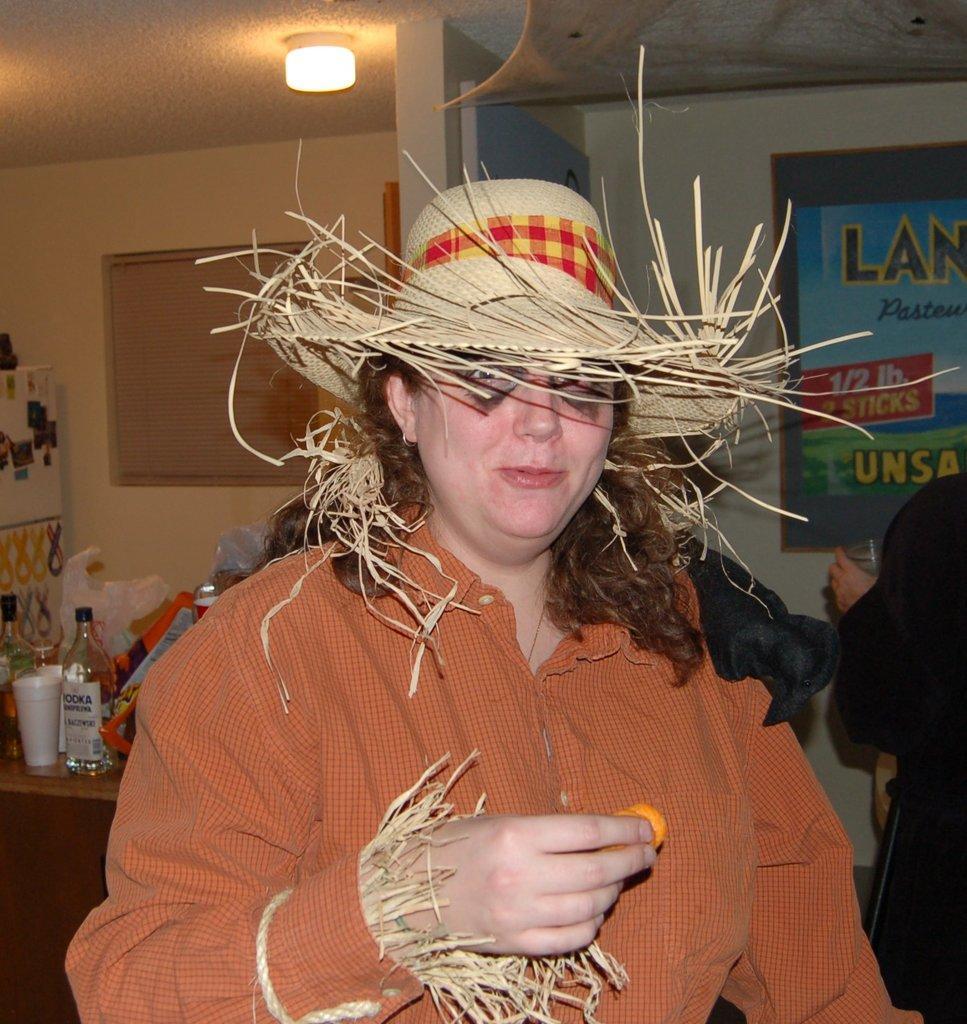Could you give a brief overview of what you see in this image? The picture consists of a woman in red shirt and wearing a hat, behind her there is a table. On the table there bottles, covers, boxes and other objects. On the right there is a person holding glass. At the top there is light to the ceiling and there is another object. At the top right there is a poster. At the top left it is window. 